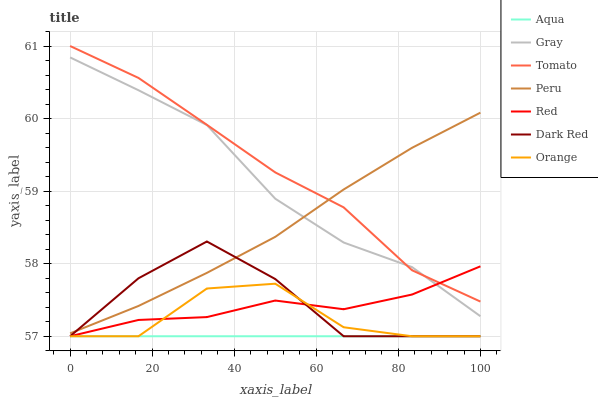Does Aqua have the minimum area under the curve?
Answer yes or no. Yes. Does Tomato have the maximum area under the curve?
Answer yes or no. Yes. Does Gray have the minimum area under the curve?
Answer yes or no. No. Does Gray have the maximum area under the curve?
Answer yes or no. No. Is Aqua the smoothest?
Answer yes or no. Yes. Is Orange the roughest?
Answer yes or no. Yes. Is Gray the smoothest?
Answer yes or no. No. Is Gray the roughest?
Answer yes or no. No. Does Dark Red have the lowest value?
Answer yes or no. Yes. Does Gray have the lowest value?
Answer yes or no. No. Does Tomato have the highest value?
Answer yes or no. Yes. Does Gray have the highest value?
Answer yes or no. No. Is Orange less than Peru?
Answer yes or no. Yes. Is Peru greater than Orange?
Answer yes or no. Yes. Does Red intersect Tomato?
Answer yes or no. Yes. Is Red less than Tomato?
Answer yes or no. No. Is Red greater than Tomato?
Answer yes or no. No. Does Orange intersect Peru?
Answer yes or no. No. 